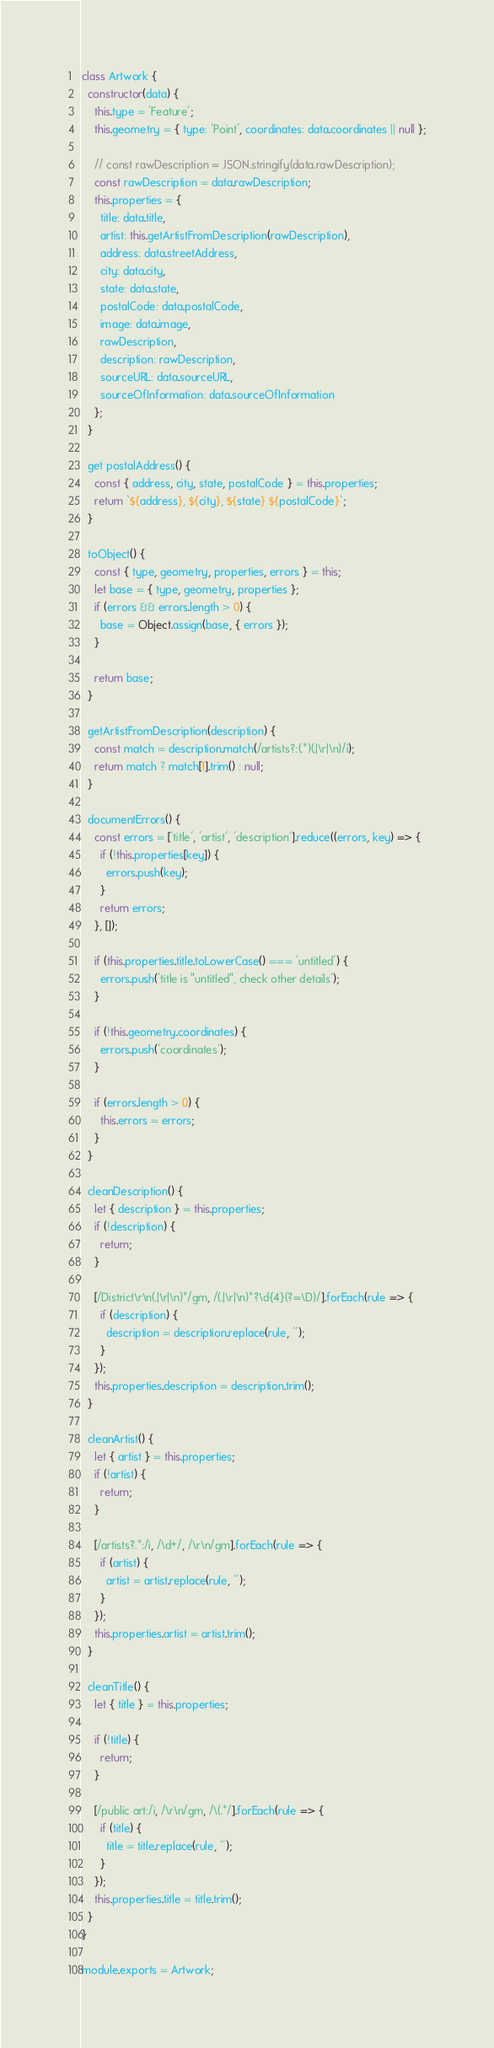Convert code to text. <code><loc_0><loc_0><loc_500><loc_500><_JavaScript_>class Artwork {
  constructor(data) {
    this.type = 'Feature';
    this.geometry = { type: 'Point', coordinates: data.coordinates || null };

    // const rawDescription = JSON.stringify(data.rawDescription);
    const rawDescription = data.rawDescription;
    this.properties = {
      title: data.title,
      artist: this.getArtistFromDescription(rawDescription),
      address: data.streetAddress,
      city: data.city,
      state: data.state,
      postalCode: data.postalCode,
      image: data.image,
      rawDescription,
      description: rawDescription,
      sourceURL: data.sourceURL,
      sourceOfInformation: data.sourceOfInformation
    };
  }

  get postalAddress() {
    const { address, city, state, postalCode } = this.properties;
    return `${address}, ${city}, ${state} ${postalCode}`;
  }

  toObject() {
    const { type, geometry, properties, errors } = this;
    let base = { type, geometry, properties };
    if (errors && errors.length > 0) {
      base = Object.assign(base, { errors });
    }

    return base;
  }

  getArtistFromDescription(description) {
    const match = description.match(/artists?:(.*)(.|\r|\n)/i);
    return match ? match[1].trim() : null;
  }

  documentErrors() {
    const errors = ['title', 'artist', 'description'].reduce((errors, key) => {
      if (!this.properties[key]) {
        errors.push(key);
      }
      return errors;
    }, []);

    if (this.properties.title.toLowerCase() === 'untitled') {
      errors.push('title is "untitled", check other details');
    }

    if (!this.geometry.coordinates) {
      errors.push('coordinates');
    }

    if (errors.length > 0) {
      this.errors = errors;
    }
  }

  cleanDescription() {
    let { description } = this.properties;
    if (!description) {
      return;
    }

    [/District\r\n(.|\r|\n)*/gm, /(.|\r|\n)*?\d{4}(?=\D)/].forEach(rule => {
      if (description) {
        description = description.replace(rule, '');
      }
    });
    this.properties.description = description.trim();
  }

  cleanArtist() {
    let { artist } = this.properties;
    if (!artist) {
      return;
    }

    [/artists?.*:/i, /\d+/, /\r\n/gm].forEach(rule => {
      if (artist) {
        artist = artist.replace(rule, '');
      }
    });
    this.properties.artist = artist.trim();
  }

  cleanTitle() {
    let { title } = this.properties;

    if (!title) {
      return;
    }

    [/public art:/i, /\r\n/gm, /\(.*/].forEach(rule => {
      if (title) {
        title = title.replace(rule, '');
      }
    });
    this.properties.title = title.trim();
  }
}

module.exports = Artwork;
</code> 